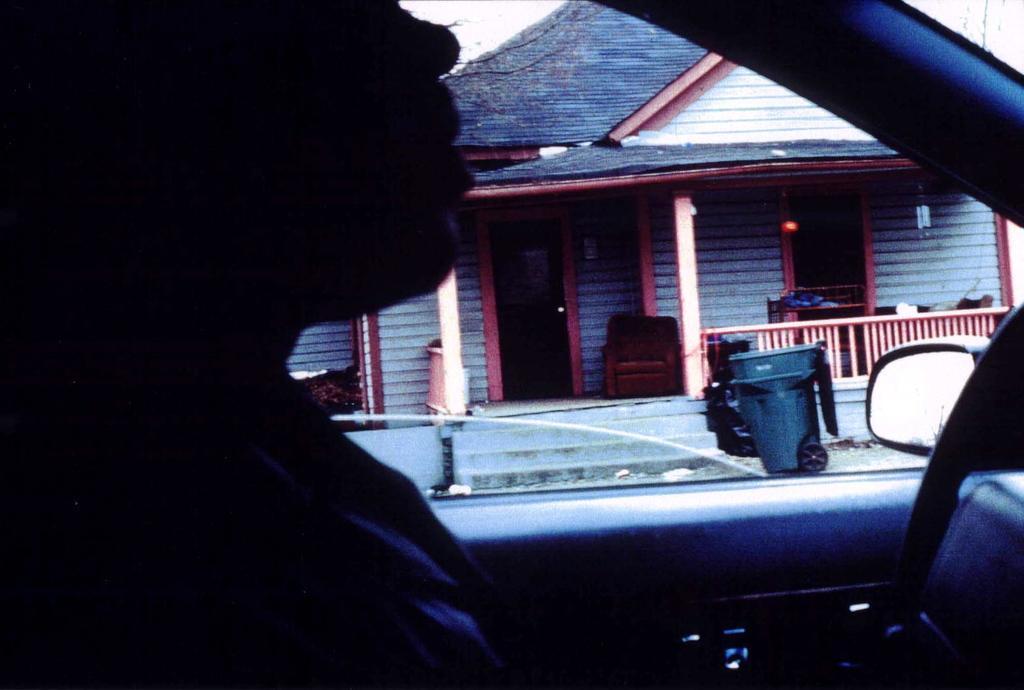In one or two sentences, can you explain what this image depicts? In this image we can see a person inside a vehicle. Here we can see a mirror, bin, poles, railing, house, chair, sky, and few objects. 